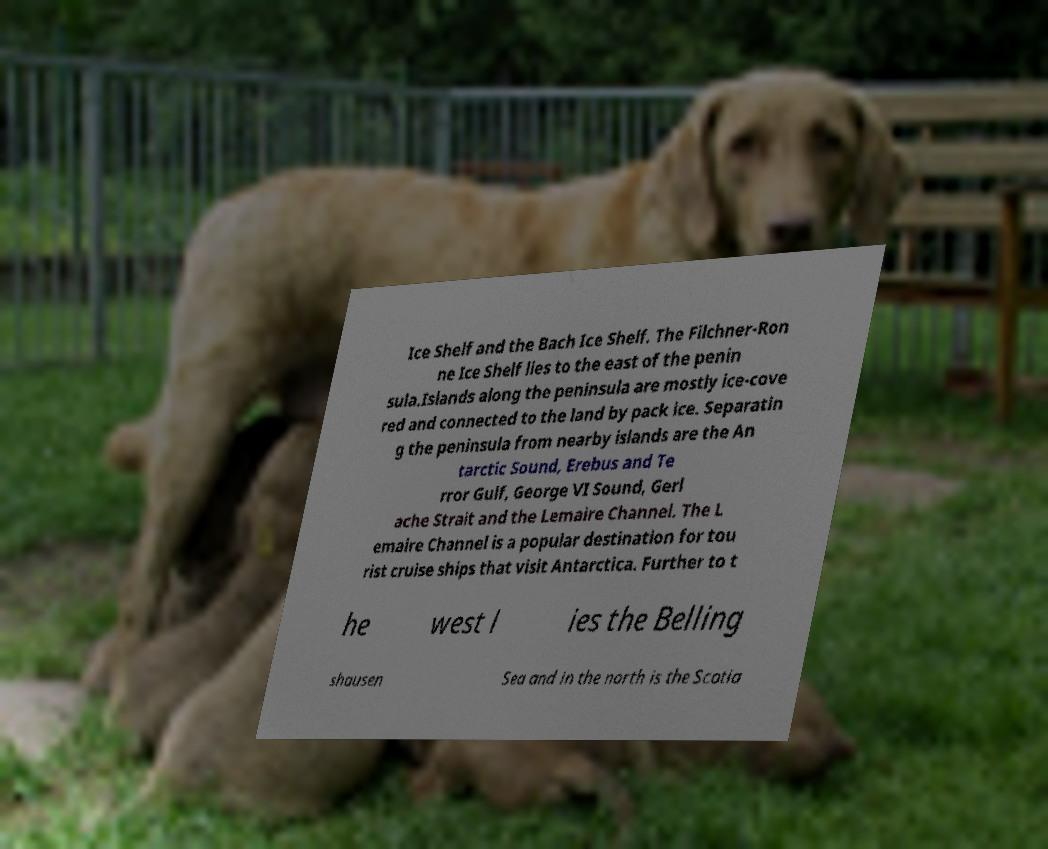I need the written content from this picture converted into text. Can you do that? Ice Shelf and the Bach Ice Shelf. The Filchner-Ron ne Ice Shelf lies to the east of the penin sula.Islands along the peninsula are mostly ice-cove red and connected to the land by pack ice. Separatin g the peninsula from nearby islands are the An tarctic Sound, Erebus and Te rror Gulf, George VI Sound, Gerl ache Strait and the Lemaire Channel. The L emaire Channel is a popular destination for tou rist cruise ships that visit Antarctica. Further to t he west l ies the Belling shausen Sea and in the north is the Scotia 